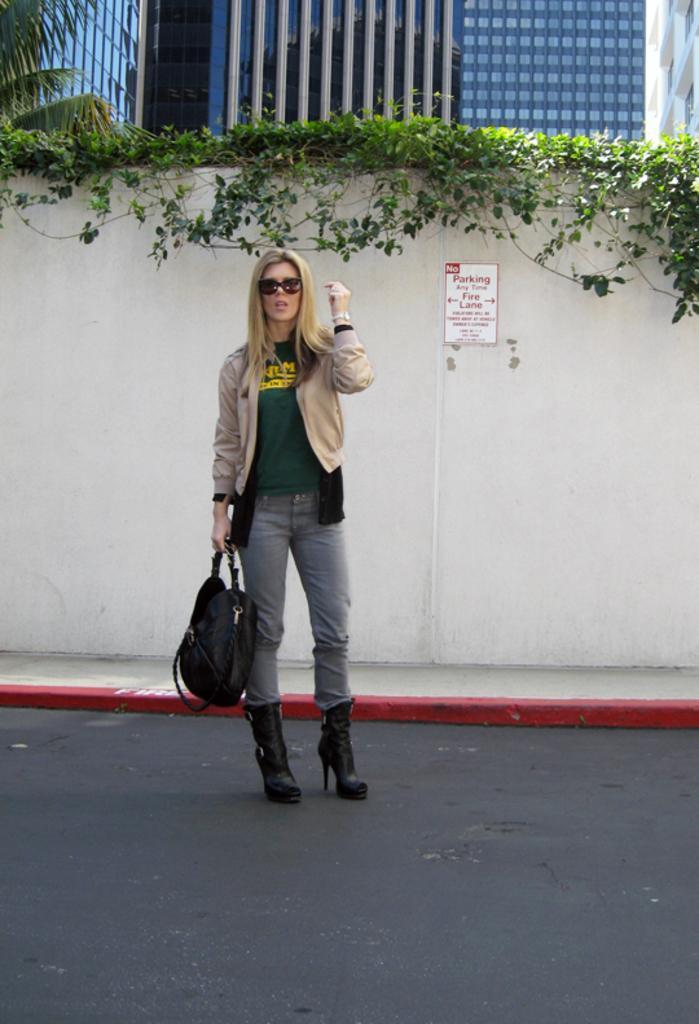Can you describe this image briefly? In this image there is a woman standing in the middle, she is carrying a bag. Back of her is a wall it consists a parking note. Behind the wall there are buildings and a tree. 